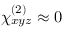<formula> <loc_0><loc_0><loc_500><loc_500>\chi _ { x y z } ^ { ( 2 ) } \approx 0</formula> 